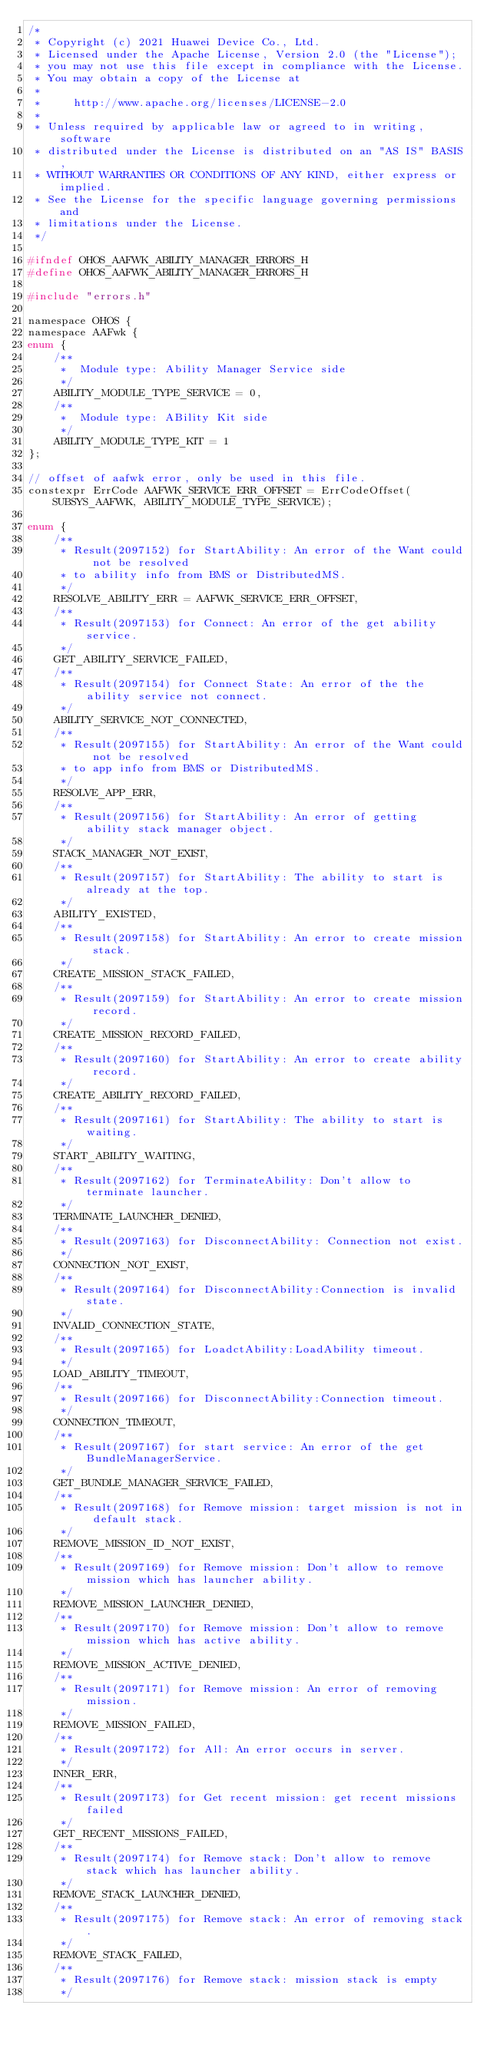Convert code to text. <code><loc_0><loc_0><loc_500><loc_500><_C_>/*
 * Copyright (c) 2021 Huawei Device Co., Ltd.
 * Licensed under the Apache License, Version 2.0 (the "License");
 * you may not use this file except in compliance with the License.
 * You may obtain a copy of the License at
 *
 *     http://www.apache.org/licenses/LICENSE-2.0
 *
 * Unless required by applicable law or agreed to in writing, software
 * distributed under the License is distributed on an "AS IS" BASIS,
 * WITHOUT WARRANTIES OR CONDITIONS OF ANY KIND, either express or implied.
 * See the License for the specific language governing permissions and
 * limitations under the License.
 */

#ifndef OHOS_AAFWK_ABILITY_MANAGER_ERRORS_H
#define OHOS_AAFWK_ABILITY_MANAGER_ERRORS_H

#include "errors.h"

namespace OHOS {
namespace AAFwk {
enum {
    /**
     *  Module type: Ability Manager Service side
     */
    ABILITY_MODULE_TYPE_SERVICE = 0,
    /**
     *  Module type: ABility Kit side
     */
    ABILITY_MODULE_TYPE_KIT = 1
};

// offset of aafwk error, only be used in this file.
constexpr ErrCode AAFWK_SERVICE_ERR_OFFSET = ErrCodeOffset(SUBSYS_AAFWK, ABILITY_MODULE_TYPE_SERVICE);

enum {
    /**
     * Result(2097152) for StartAbility: An error of the Want could not be resolved
     * to ability info from BMS or DistributedMS.
     */
    RESOLVE_ABILITY_ERR = AAFWK_SERVICE_ERR_OFFSET,
    /**
     * Result(2097153) for Connect: An error of the get ability service.
     */
    GET_ABILITY_SERVICE_FAILED,
    /**
     * Result(2097154) for Connect State: An error of the the ability service not connect.
     */
    ABILITY_SERVICE_NOT_CONNECTED,
    /**
     * Result(2097155) for StartAbility: An error of the Want could not be resolved
     * to app info from BMS or DistributedMS.
     */
    RESOLVE_APP_ERR,
    /**
     * Result(2097156) for StartAbility: An error of getting ability stack manager object.
     */
    STACK_MANAGER_NOT_EXIST,
    /**
     * Result(2097157) for StartAbility: The ability to start is already at the top.
     */
    ABILITY_EXISTED,
    /**
     * Result(2097158) for StartAbility: An error to create mission stack.
     */
    CREATE_MISSION_STACK_FAILED,
    /**
     * Result(2097159) for StartAbility: An error to create mission record.
     */
    CREATE_MISSION_RECORD_FAILED,
    /**
     * Result(2097160) for StartAbility: An error to create ability record.
     */
    CREATE_ABILITY_RECORD_FAILED,
    /**
     * Result(2097161) for StartAbility: The ability to start is waiting.
     */
    START_ABILITY_WAITING,
    /**
     * Result(2097162) for TerminateAbility: Don't allow to terminate launcher.
     */
    TERMINATE_LAUNCHER_DENIED,
    /**
     * Result(2097163) for DisconnectAbility: Connection not exist.
     */
    CONNECTION_NOT_EXIST,
    /**
     * Result(2097164) for DisconnectAbility:Connection is invalid state.
     */
    INVALID_CONNECTION_STATE,
    /**
     * Result(2097165) for LoadctAbility:LoadAbility timeout.
     */
    LOAD_ABILITY_TIMEOUT,
    /**
     * Result(2097166) for DisconnectAbility:Connection timeout.
     */
    CONNECTION_TIMEOUT,
    /**
     * Result(2097167) for start service: An error of the get BundleManagerService.
     */
    GET_BUNDLE_MANAGER_SERVICE_FAILED,
    /**
     * Result(2097168) for Remove mission: target mission is not in default stack.
     */
    REMOVE_MISSION_ID_NOT_EXIST,
    /**
     * Result(2097169) for Remove mission: Don't allow to remove mission which has launcher ability.
     */
    REMOVE_MISSION_LAUNCHER_DENIED,
    /**
     * Result(2097170) for Remove mission: Don't allow to remove mission which has active ability.
     */
    REMOVE_MISSION_ACTIVE_DENIED,
    /**
     * Result(2097171) for Remove mission: An error of removing mission.
     */
    REMOVE_MISSION_FAILED,
    /**
     * Result(2097172) for All: An error occurs in server.
     */
    INNER_ERR,
    /**
     * Result(2097173) for Get recent mission: get recent missions failed
     */
    GET_RECENT_MISSIONS_FAILED,
    /**
     * Result(2097174) for Remove stack: Don't allow to remove stack which has launcher ability.
     */
    REMOVE_STACK_LAUNCHER_DENIED,
    /**
     * Result(2097175) for Remove stack: An error of removing stack.
     */
    REMOVE_STACK_FAILED,
    /**
     * Result(2097176) for Remove stack: mission stack is empty
     */</code> 